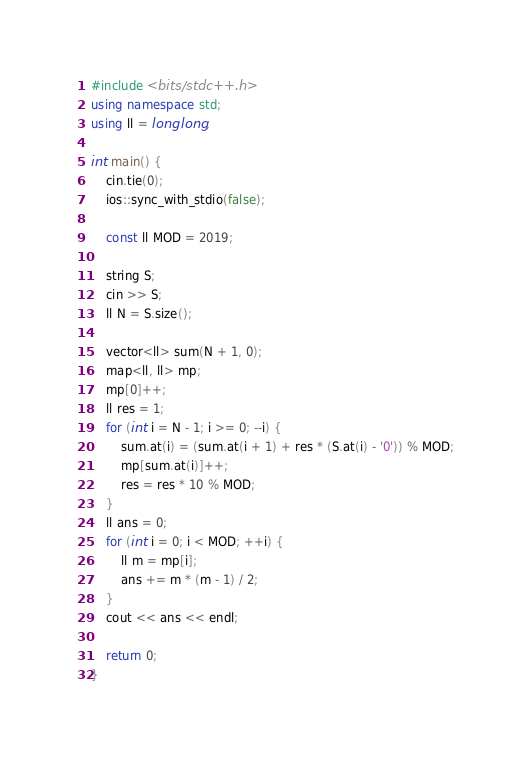Convert code to text. <code><loc_0><loc_0><loc_500><loc_500><_C++_>#include <bits/stdc++.h>
using namespace std;
using ll = long long;

int main() {
    cin.tie(0);
    ios::sync_with_stdio(false);

    const ll MOD = 2019;

    string S;
    cin >> S;
    ll N = S.size();

    vector<ll> sum(N + 1, 0);
    map<ll, ll> mp;
    mp[0]++;
    ll res = 1;
    for (int i = N - 1; i >= 0; --i) {
        sum.at(i) = (sum.at(i + 1) + res * (S.at(i) - '0')) % MOD;
        mp[sum.at(i)]++;
        res = res * 10 % MOD;
    }
    ll ans = 0;
    for (int i = 0; i < MOD; ++i) {
        ll m = mp[i];
        ans += m * (m - 1) / 2;
    }
    cout << ans << endl;

    return 0;
}</code> 